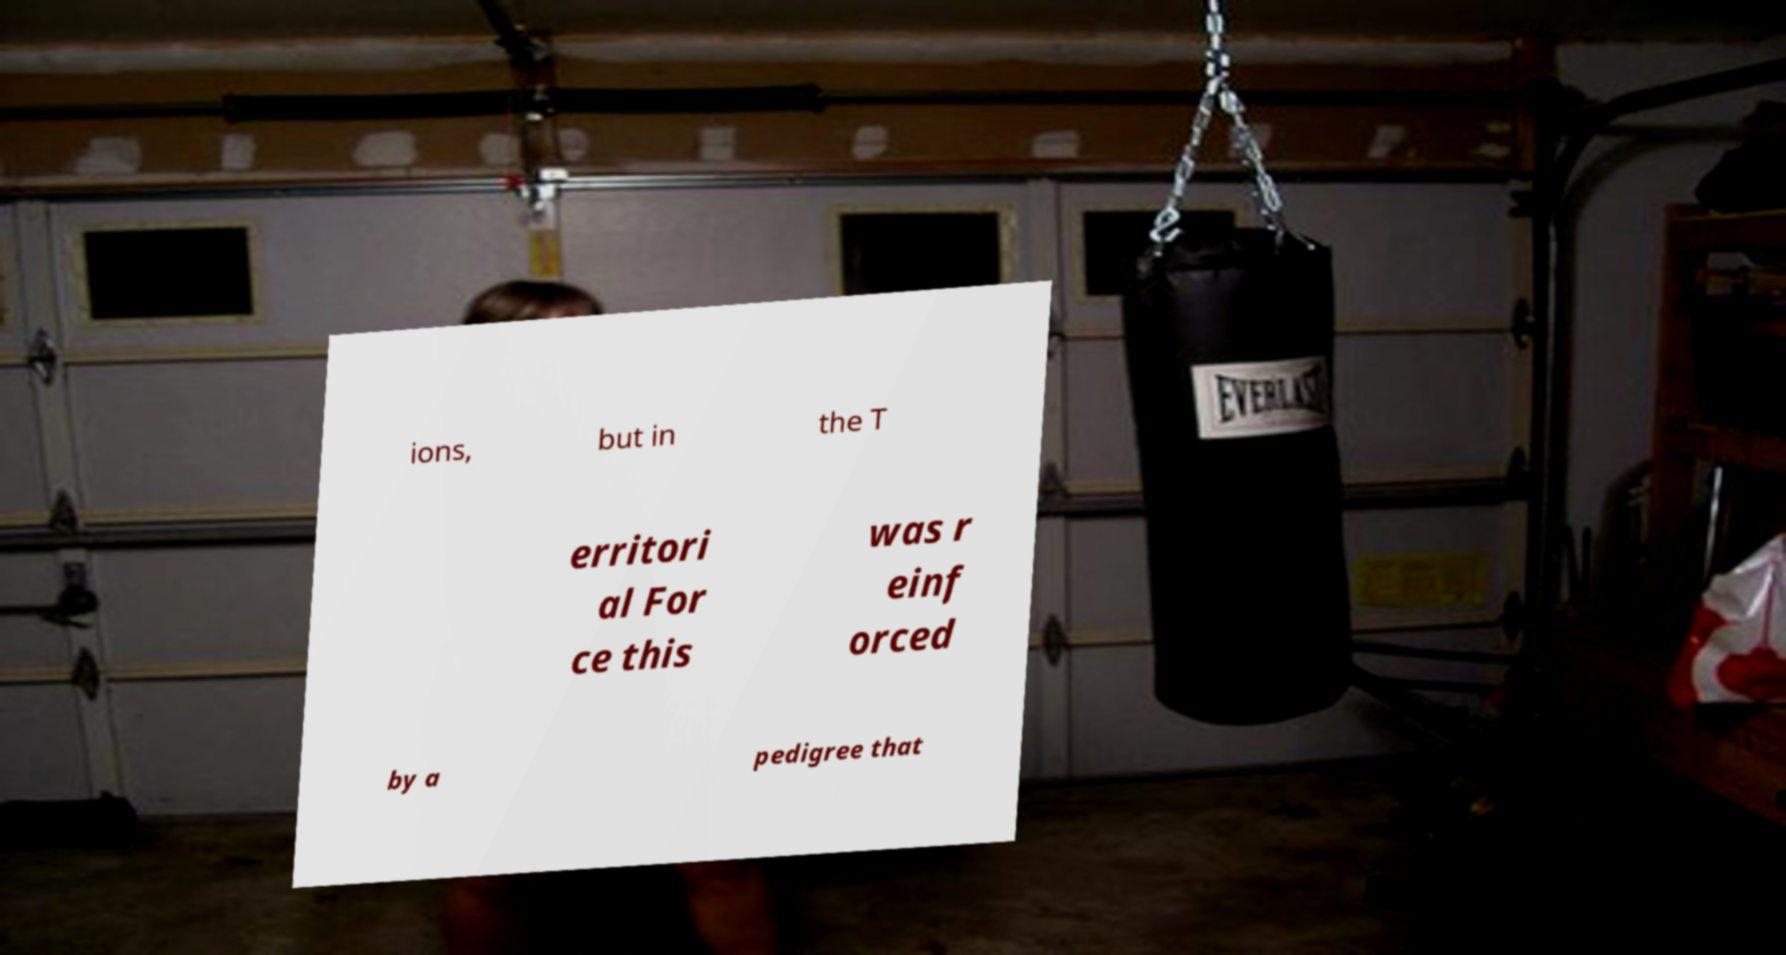There's text embedded in this image that I need extracted. Can you transcribe it verbatim? ions, but in the T erritori al For ce this was r einf orced by a pedigree that 